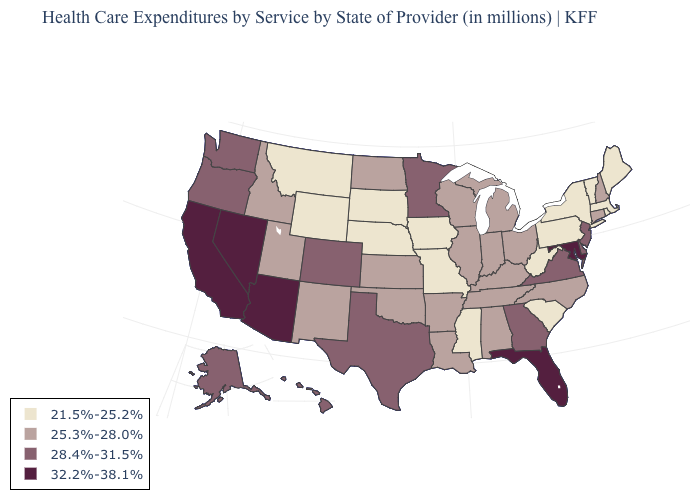What is the highest value in the Northeast ?
Write a very short answer. 28.4%-31.5%. Is the legend a continuous bar?
Keep it brief. No. What is the value of Louisiana?
Quick response, please. 25.3%-28.0%. Which states have the lowest value in the South?
Quick response, please. Mississippi, South Carolina, West Virginia. Does the map have missing data?
Quick response, please. No. What is the highest value in the Northeast ?
Short answer required. 28.4%-31.5%. How many symbols are there in the legend?
Be succinct. 4. How many symbols are there in the legend?
Short answer required. 4. What is the value of Delaware?
Be succinct. 28.4%-31.5%. Does South Carolina have the highest value in the USA?
Keep it brief. No. Does Wisconsin have the highest value in the MidWest?
Write a very short answer. No. What is the value of Wyoming?
Write a very short answer. 21.5%-25.2%. Does Delaware have a higher value than Maryland?
Give a very brief answer. No. Name the states that have a value in the range 32.2%-38.1%?
Keep it brief. Arizona, California, Florida, Maryland, Nevada. What is the highest value in the Northeast ?
Write a very short answer. 28.4%-31.5%. 